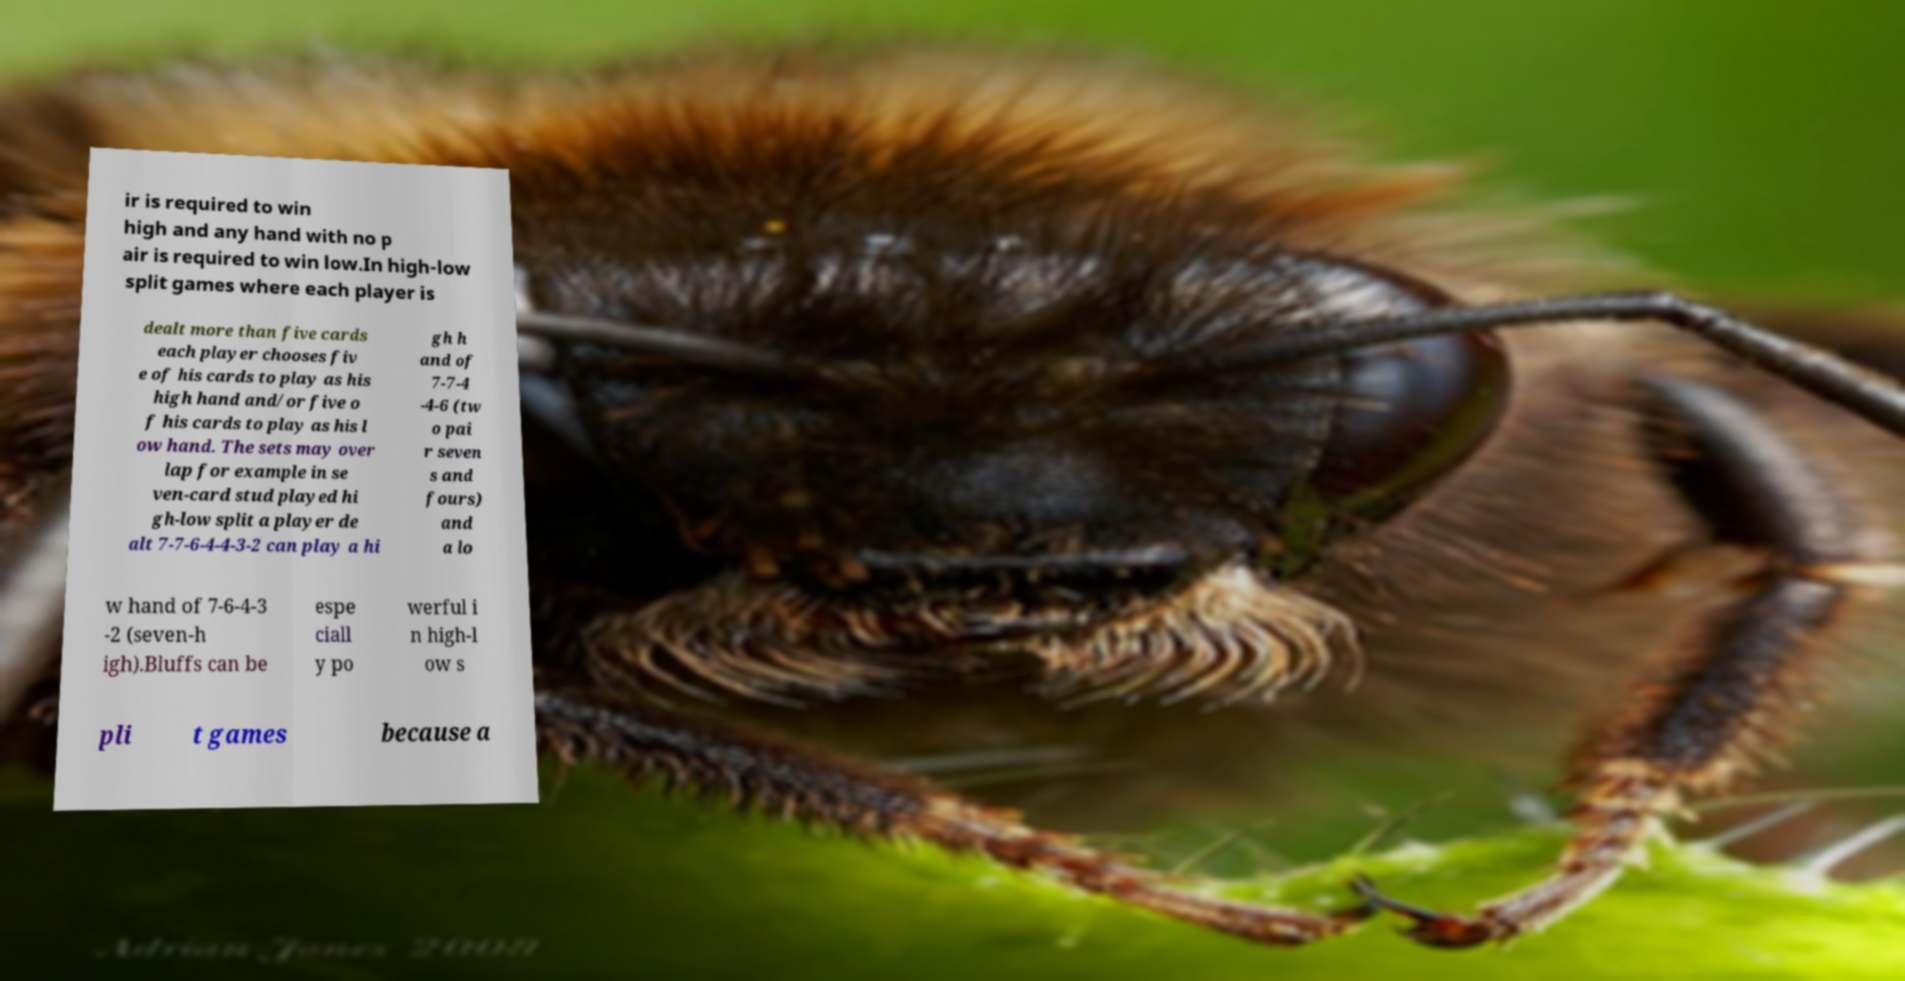Could you extract and type out the text from this image? ir is required to win high and any hand with no p air is required to win low.In high-low split games where each player is dealt more than five cards each player chooses fiv e of his cards to play as his high hand and/or five o f his cards to play as his l ow hand. The sets may over lap for example in se ven-card stud played hi gh-low split a player de alt 7-7-6-4-4-3-2 can play a hi gh h and of 7-7-4 -4-6 (tw o pai r seven s and fours) and a lo w hand of 7-6-4-3 -2 (seven-h igh).Bluffs can be espe ciall y po werful i n high-l ow s pli t games because a 